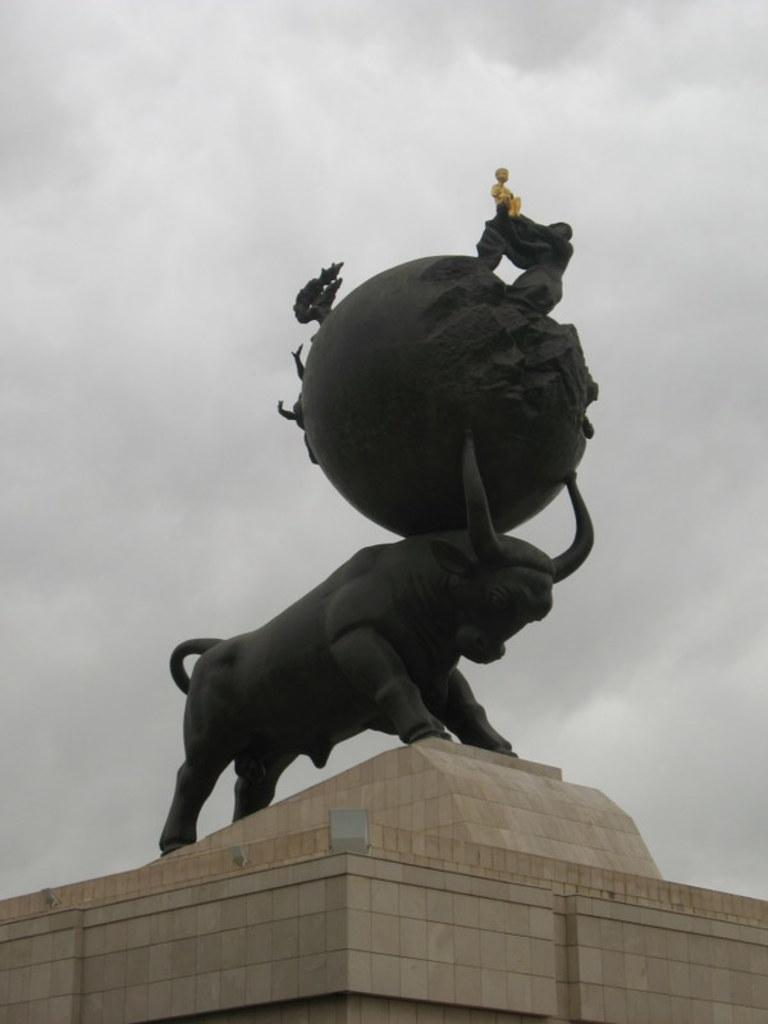Could you give a brief overview of what you see in this image? In the center of the image there is a statue. In the background we can see sky and clouds. 